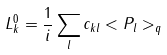<formula> <loc_0><loc_0><loc_500><loc_500>L ^ { 0 } _ { k } = \frac { 1 } { i } \sum _ { l } c _ { k l } < P _ { l } > _ { q }</formula> 